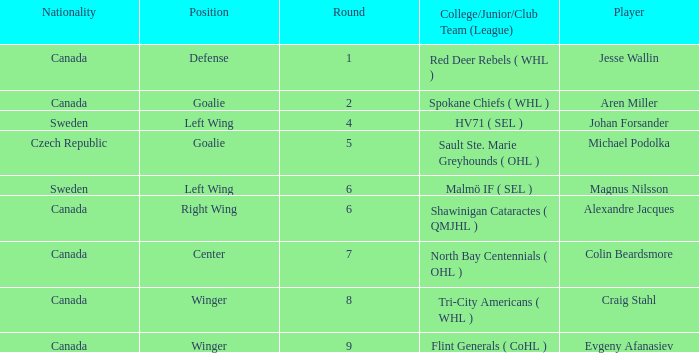What is the School/Junior/Club Group (Class) that has a Nationality of canada, and a Place of goalie? Spokane Chiefs ( WHL ). 